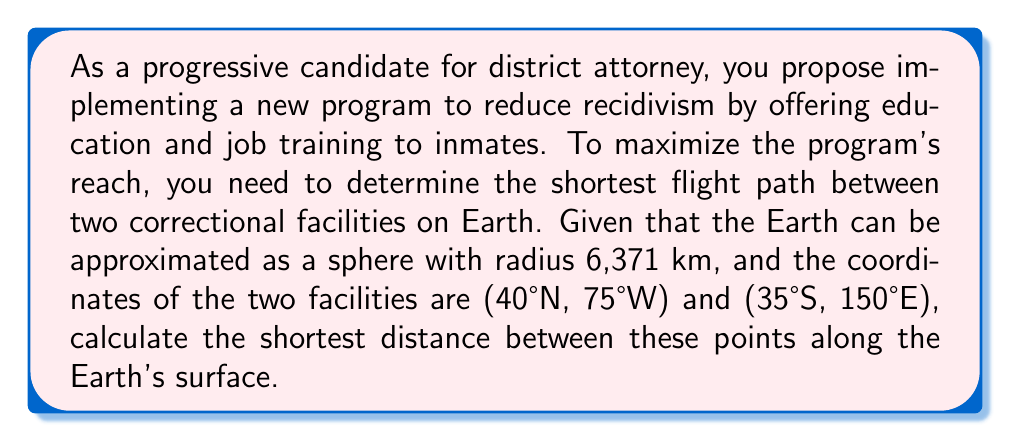Can you solve this math problem? To solve this problem, we'll use the great circle distance formula, which gives the shortest path between two points on a sphere. The steps are as follows:

1. Convert the coordinates from degrees to radians:
   $\phi_1 = 40° \cdot \frac{\pi}{180} = 0.6981$ rad
   $\lambda_1 = -75° \cdot \frac{\pi}{180} = -1.3090$ rad
   $\phi_2 = -35° \cdot \frac{\pi}{180} = -0.6109$ rad
   $\lambda_2 = 150° \cdot \frac{\pi}{180} = 2.6180$ rad

2. Calculate the central angle $\Delta\sigma$ using the Haversine formula:
   $$\Delta\sigma = 2 \arcsin\left(\sqrt{\sin^2\left(\frac{\phi_2-\phi_1}{2}\right) + \cos\phi_1 \cos\phi_2 \sin^2\left(\frac{\lambda_2-\lambda_1}{2}\right)}\right)$$

3. Substitute the values:
   $$\Delta\sigma = 2 \arcsin\left(\sqrt{\sin^2\left(\frac{-0.6109-0.6981}{2}\right) + \cos(0.6981) \cos(-0.6109) \sin^2\left(\frac{2.6180-(-1.3090)}{2}\right)}\right)$$

4. Calculate:
   $$\Delta\sigma = 2 \arcsin(\sqrt{0.4257 + 0.3197 \cdot 0.8660}) = 2.3305$$

5. The shortest distance $d$ is the product of the Earth's radius $R$ and the central angle:
   $$d = R \cdot \Delta\sigma = 6371 \text{ km} \cdot 2.3305 = 14,847 \text{ km}$$
Answer: 14,847 km 